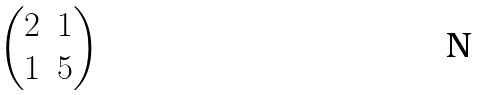<formula> <loc_0><loc_0><loc_500><loc_500>\begin{pmatrix} 2 & 1 \\ 1 & 5 \end{pmatrix}</formula> 